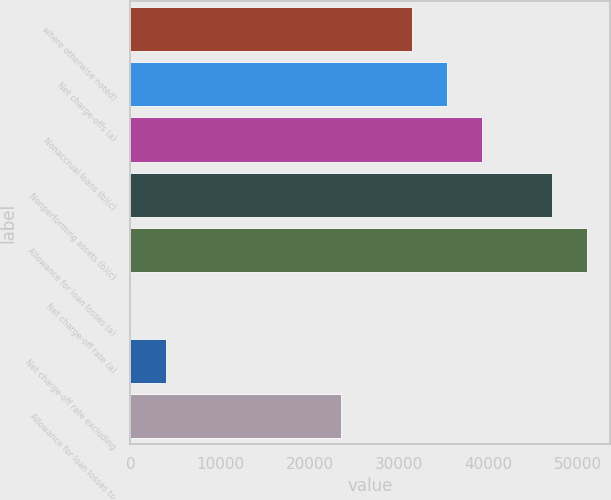<chart> <loc_0><loc_0><loc_500><loc_500><bar_chart><fcel>where otherwise noted)<fcel>Net charge-offs (a)<fcel>Nonaccrual loans (b)(c)<fcel>Nonperforming assets (b)(c)<fcel>Allowance for loan losses (a)<fcel>Net charge-off rate (a)<fcel>Net charge-off rate excluding<fcel>Allowance for loan losses to<nl><fcel>31393.8<fcel>35317.9<fcel>39242<fcel>47090.2<fcel>51014.3<fcel>0.99<fcel>3925.09<fcel>23545.6<nl></chart> 